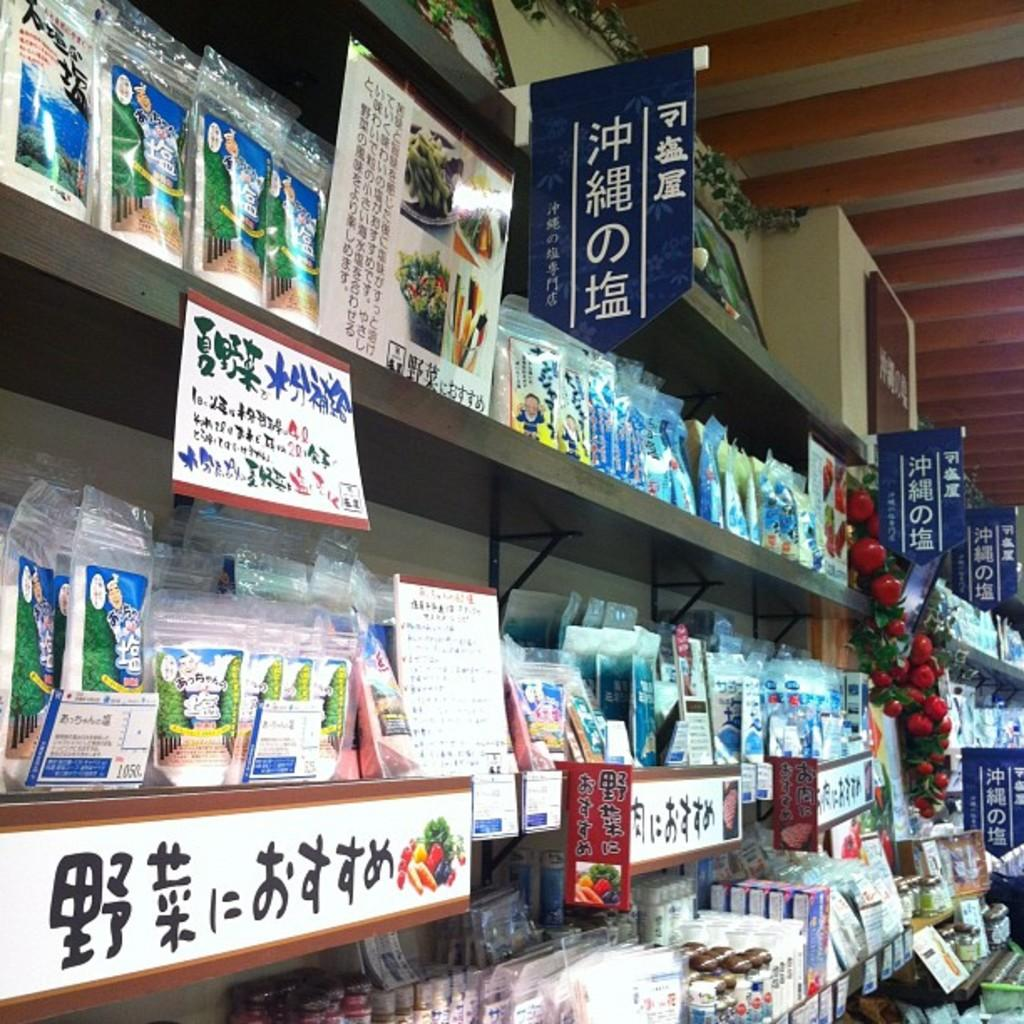<image>
Describe the image concisely. shelves of different asian labeled items, one far left has number 1050 on it 